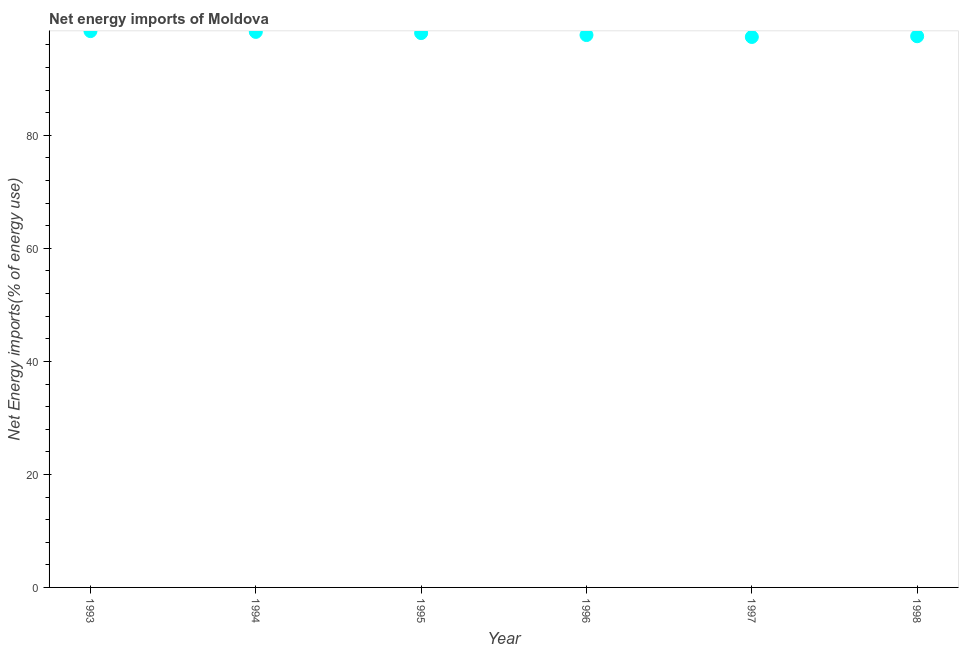What is the energy imports in 1998?
Your response must be concise. 97.54. Across all years, what is the maximum energy imports?
Offer a very short reply. 98.45. Across all years, what is the minimum energy imports?
Your response must be concise. 97.41. In which year was the energy imports maximum?
Offer a very short reply. 1993. What is the sum of the energy imports?
Offer a very short reply. 587.57. What is the difference between the energy imports in 1993 and 1995?
Provide a succinct answer. 0.35. What is the average energy imports per year?
Make the answer very short. 97.93. What is the median energy imports?
Your answer should be very brief. 97.93. Do a majority of the years between 1996 and 1993 (inclusive) have energy imports greater than 8 %?
Provide a succinct answer. Yes. What is the ratio of the energy imports in 1995 to that in 1997?
Your answer should be very brief. 1.01. Is the energy imports in 1995 less than that in 1997?
Keep it short and to the point. No. Is the difference between the energy imports in 1993 and 1998 greater than the difference between any two years?
Your answer should be very brief. No. What is the difference between the highest and the second highest energy imports?
Provide a succinct answer. 0.14. Is the sum of the energy imports in 1997 and 1998 greater than the maximum energy imports across all years?
Your answer should be very brief. Yes. What is the difference between the highest and the lowest energy imports?
Provide a short and direct response. 1.04. How many years are there in the graph?
Offer a terse response. 6. Does the graph contain grids?
Offer a terse response. No. What is the title of the graph?
Your answer should be compact. Net energy imports of Moldova. What is the label or title of the Y-axis?
Make the answer very short. Net Energy imports(% of energy use). What is the Net Energy imports(% of energy use) in 1993?
Your answer should be compact. 98.45. What is the Net Energy imports(% of energy use) in 1994?
Offer a terse response. 98.31. What is the Net Energy imports(% of energy use) in 1995?
Provide a succinct answer. 98.1. What is the Net Energy imports(% of energy use) in 1996?
Provide a succinct answer. 97.76. What is the Net Energy imports(% of energy use) in 1997?
Your answer should be compact. 97.41. What is the Net Energy imports(% of energy use) in 1998?
Offer a terse response. 97.54. What is the difference between the Net Energy imports(% of energy use) in 1993 and 1994?
Keep it short and to the point. 0.14. What is the difference between the Net Energy imports(% of energy use) in 1993 and 1995?
Your response must be concise. 0.35. What is the difference between the Net Energy imports(% of energy use) in 1993 and 1996?
Ensure brevity in your answer.  0.69. What is the difference between the Net Energy imports(% of energy use) in 1993 and 1997?
Your answer should be compact. 1.04. What is the difference between the Net Energy imports(% of energy use) in 1993 and 1998?
Your response must be concise. 0.91. What is the difference between the Net Energy imports(% of energy use) in 1994 and 1995?
Ensure brevity in your answer.  0.21. What is the difference between the Net Energy imports(% of energy use) in 1994 and 1996?
Make the answer very short. 0.56. What is the difference between the Net Energy imports(% of energy use) in 1994 and 1997?
Provide a short and direct response. 0.9. What is the difference between the Net Energy imports(% of energy use) in 1994 and 1998?
Provide a succinct answer. 0.77. What is the difference between the Net Energy imports(% of energy use) in 1995 and 1996?
Offer a terse response. 0.35. What is the difference between the Net Energy imports(% of energy use) in 1995 and 1997?
Keep it short and to the point. 0.69. What is the difference between the Net Energy imports(% of energy use) in 1995 and 1998?
Give a very brief answer. 0.56. What is the difference between the Net Energy imports(% of energy use) in 1996 and 1997?
Your response must be concise. 0.34. What is the difference between the Net Energy imports(% of energy use) in 1996 and 1998?
Offer a terse response. 0.21. What is the difference between the Net Energy imports(% of energy use) in 1997 and 1998?
Make the answer very short. -0.13. What is the ratio of the Net Energy imports(% of energy use) in 1993 to that in 1997?
Offer a very short reply. 1.01. What is the ratio of the Net Energy imports(% of energy use) in 1994 to that in 1998?
Make the answer very short. 1.01. What is the ratio of the Net Energy imports(% of energy use) in 1996 to that in 1997?
Provide a short and direct response. 1. 